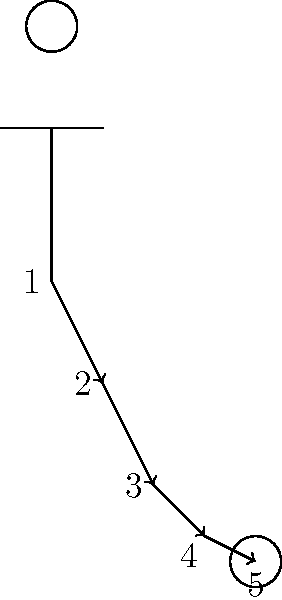In a goal kick, the kinetic chain involves a sequence of movements that transfer energy from the body to the ball. Based on the stick figure diagram, identify the correct order of the kinetic chain for an effective goal kick. The kinetic chain in a goal kick follows a specific sequence to maximize power and accuracy:

1. The movement starts at the hip (labeled "1" in the diagram). The hip flexors and extensors initiate the kick by generating rotational force.

2. This force is then transferred to the knee (labeled "2"). The quadriceps and hamstrings work together to extend the knee rapidly.

3. The ankle (labeled "3") is the next link in the chain. The calf muscles (gastrocnemius and soleus) contract to plantarflex the foot, adding more power to the kick.

4. The foot (labeled "4") is the final body part in the chain. It makes direct contact with the ball, transferring all the accumulated energy.

5. The ball (labeled "5") receives the energy and is propelled forward as a result of the entire kinetic chain working in sequence.

This sequence allows for the most efficient transfer of energy from the large muscle groups of the legs to the ball, resulting in a powerful and accurate goal kick.
Answer: Hip → Knee → Ankle → Foot → Ball 